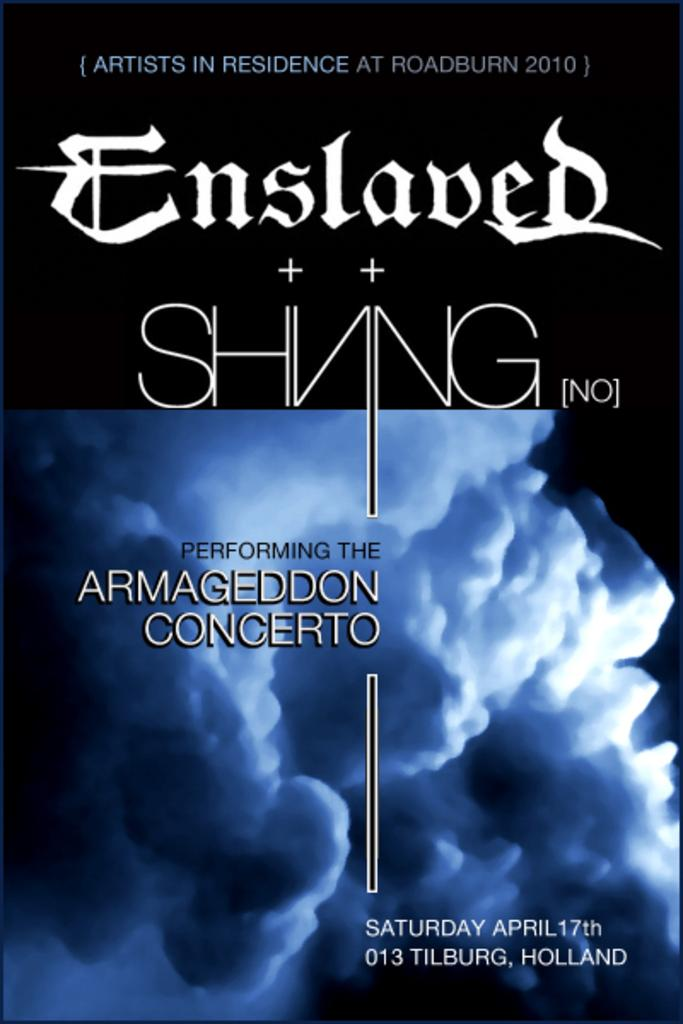<image>
Render a clear and concise summary of the photo. slaved black and blue clouds performing Armageddon written on the front. 